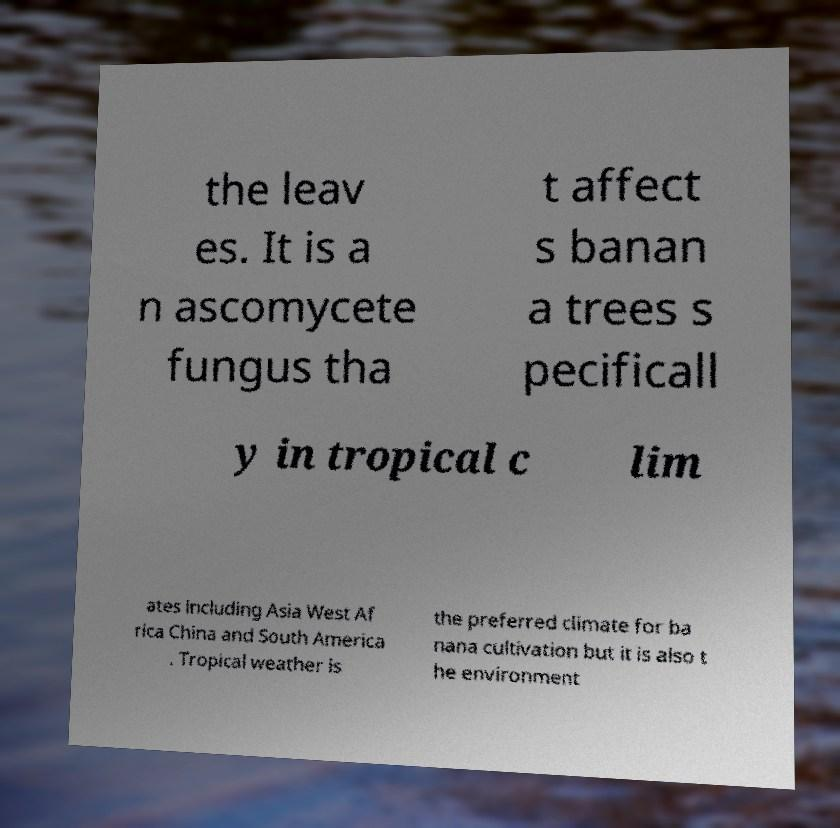For documentation purposes, I need the text within this image transcribed. Could you provide that? the leav es. It is a n ascomycete fungus tha t affect s banan a trees s pecificall y in tropical c lim ates including Asia West Af rica China and South America . Tropical weather is the preferred climate for ba nana cultivation but it is also t he environment 